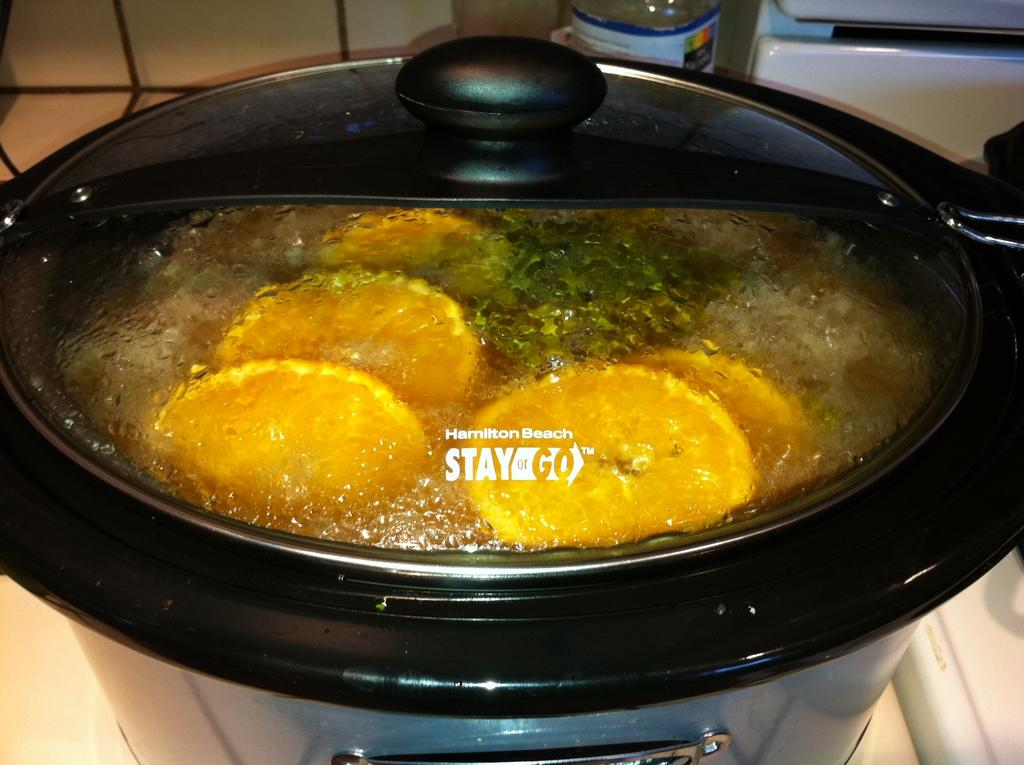<image>
Create a compact narrative representing the image presented. A kitchen appliance made by Hamilton Beach named Stay or Go. 